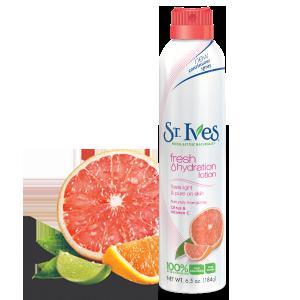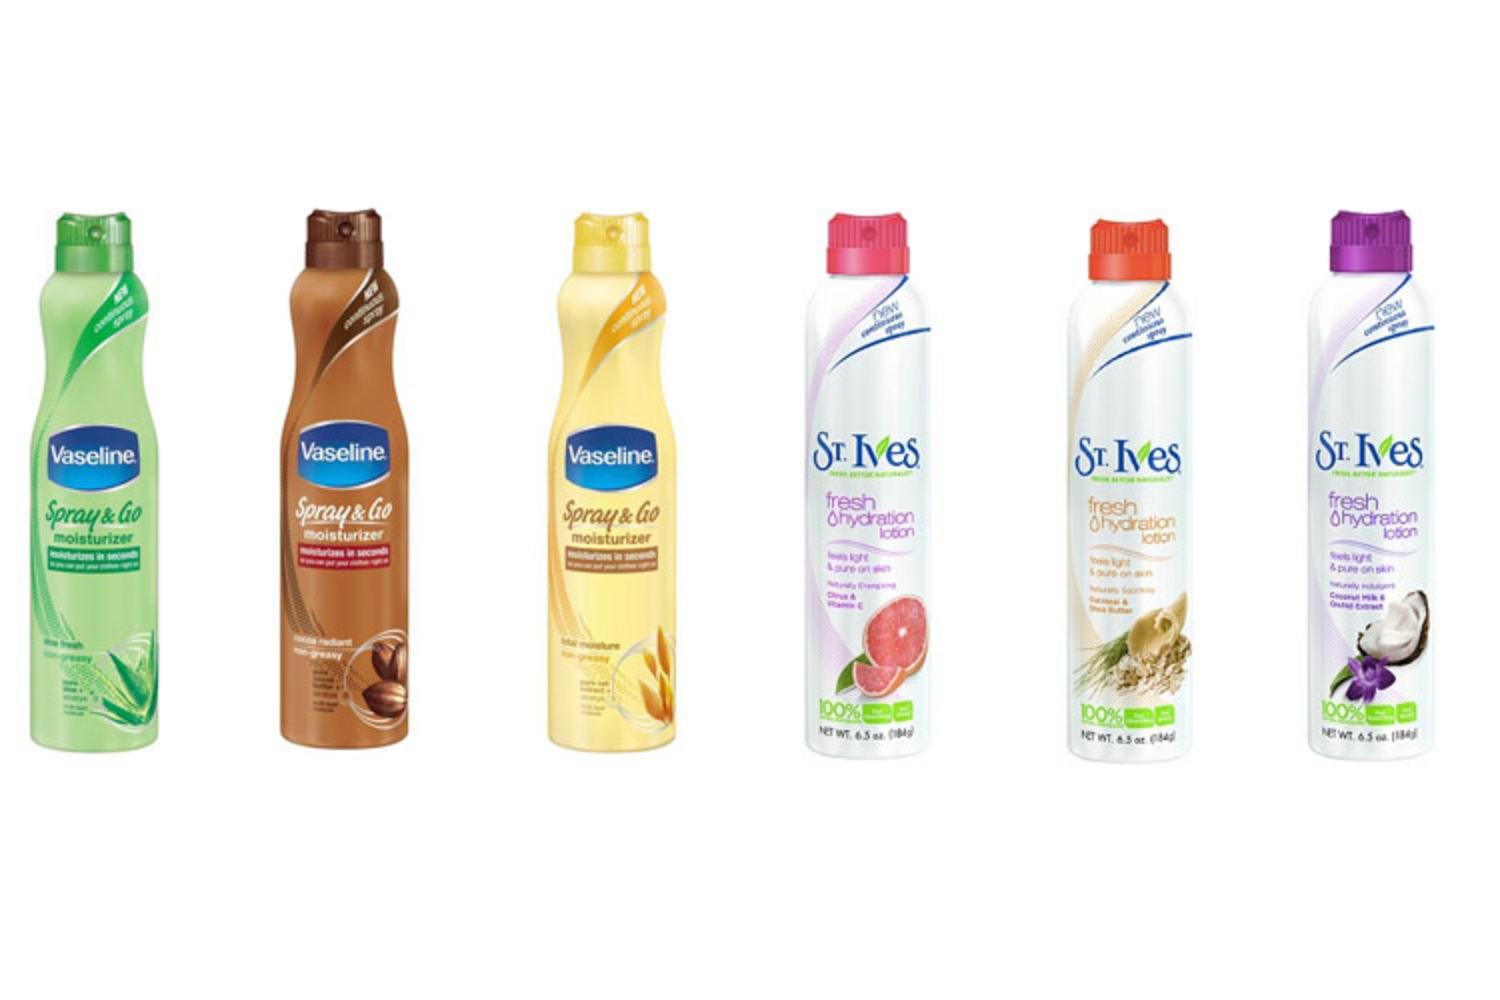The first image is the image on the left, the second image is the image on the right. Given the left and right images, does the statement "there are 7 beauty products in the image pair" hold true? Answer yes or no. Yes. The first image is the image on the left, the second image is the image on the right. Assess this claim about the two images: "The image on the left has one bottle of St. Ives Fresh Hydration Lotion in front of objects that match the objects on the bottle.". Correct or not? Answer yes or no. Yes. 